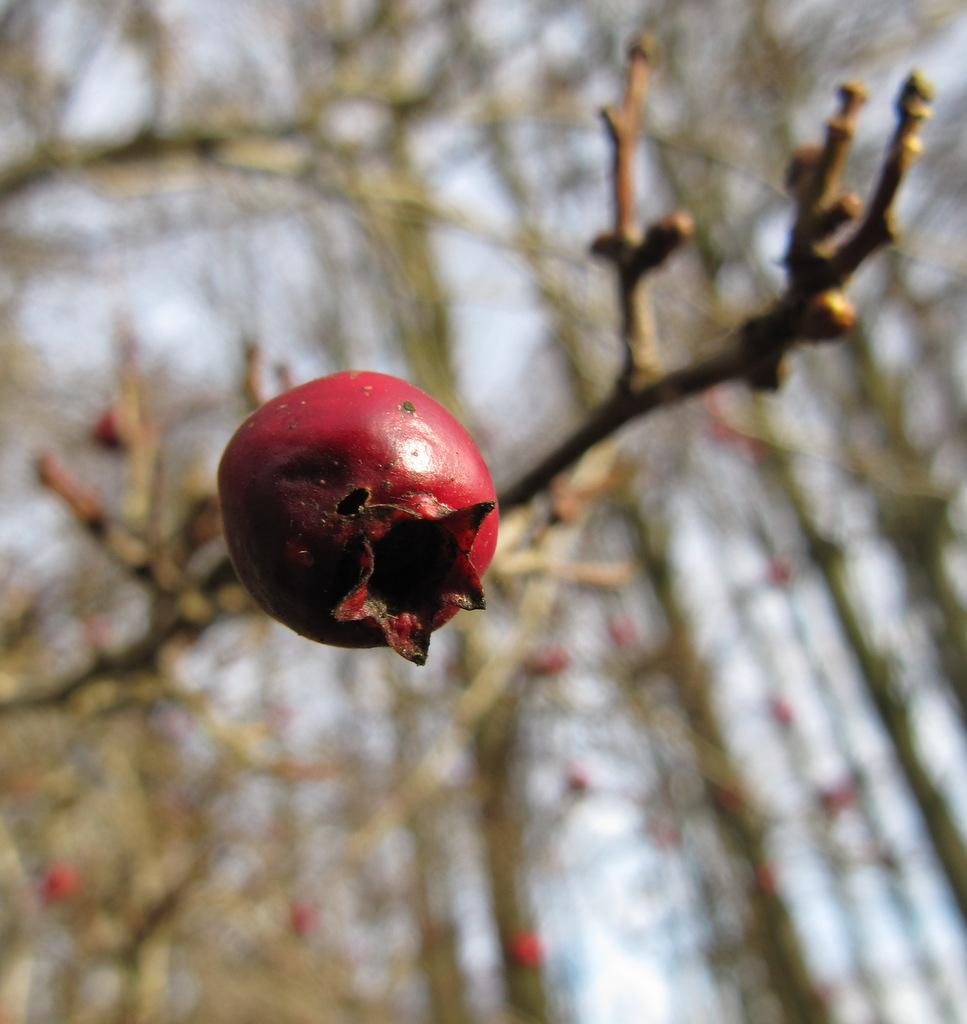What type of fruit can be seen on the tree in the image? There is a pomegranate fruit on the tree in the image. Can you describe the background of the image? The background of the image is blurred. What is the current condition of the fruit trade in the image? There is no information about fruit trade in the image, as it only shows a pomegranate fruit on a tree with a blurred background. 